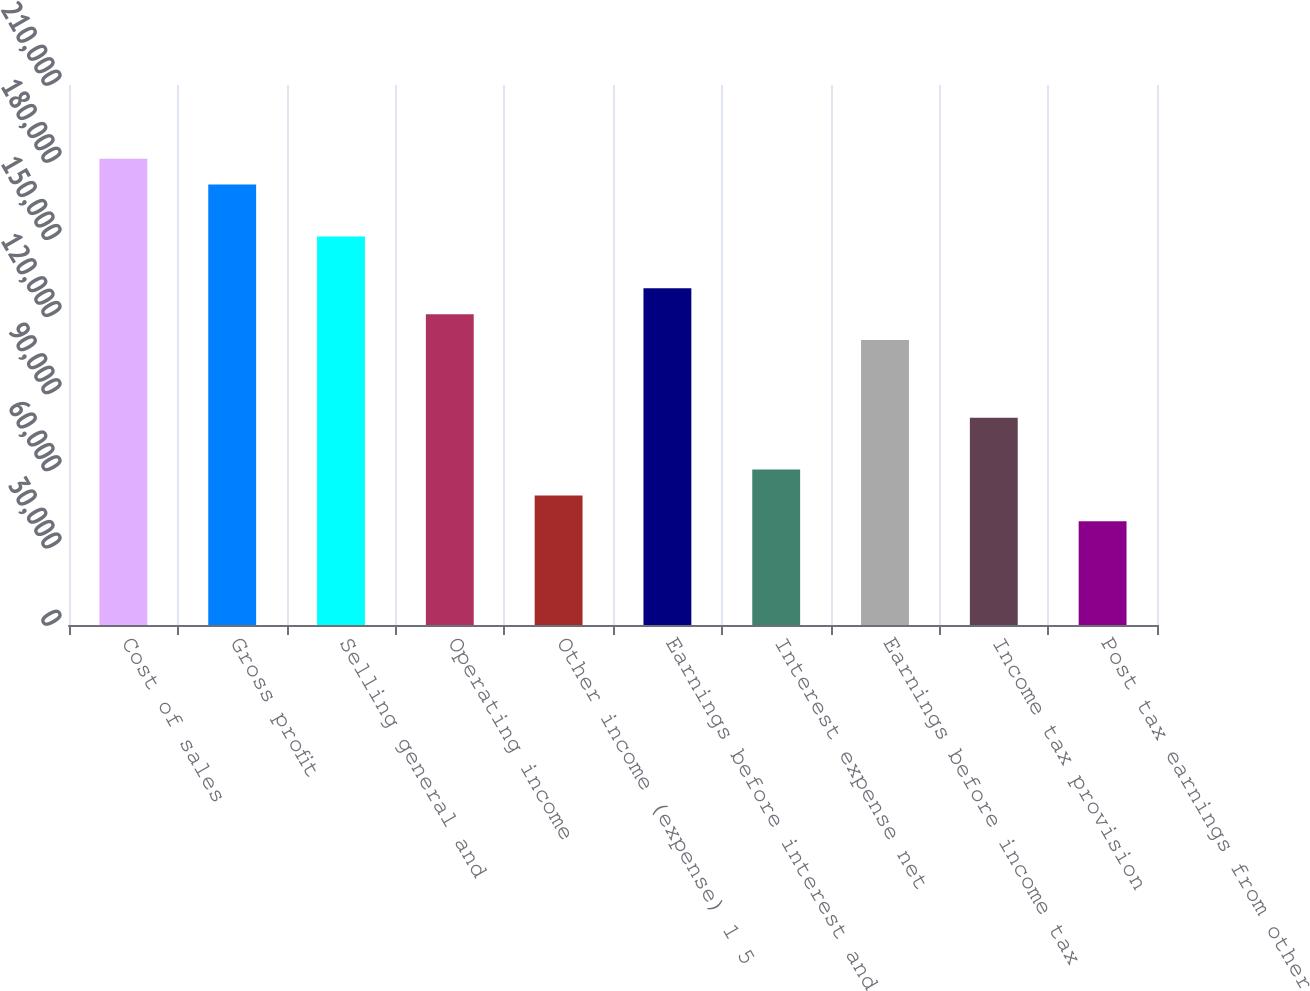<chart> <loc_0><loc_0><loc_500><loc_500><bar_chart><fcel>Cost of sales<fcel>Gross profit<fcel>Selling general and<fcel>Operating income<fcel>Other income (expense) 1 5<fcel>Earnings before interest and<fcel>Interest expense net<fcel>Earnings before income tax<fcel>Income tax provision<fcel>Post tax earnings from other<nl><fcel>181340<fcel>171265<fcel>151117<fcel>120894<fcel>50373.3<fcel>130968<fcel>60447.7<fcel>110819<fcel>80596.4<fcel>40299<nl></chart> 